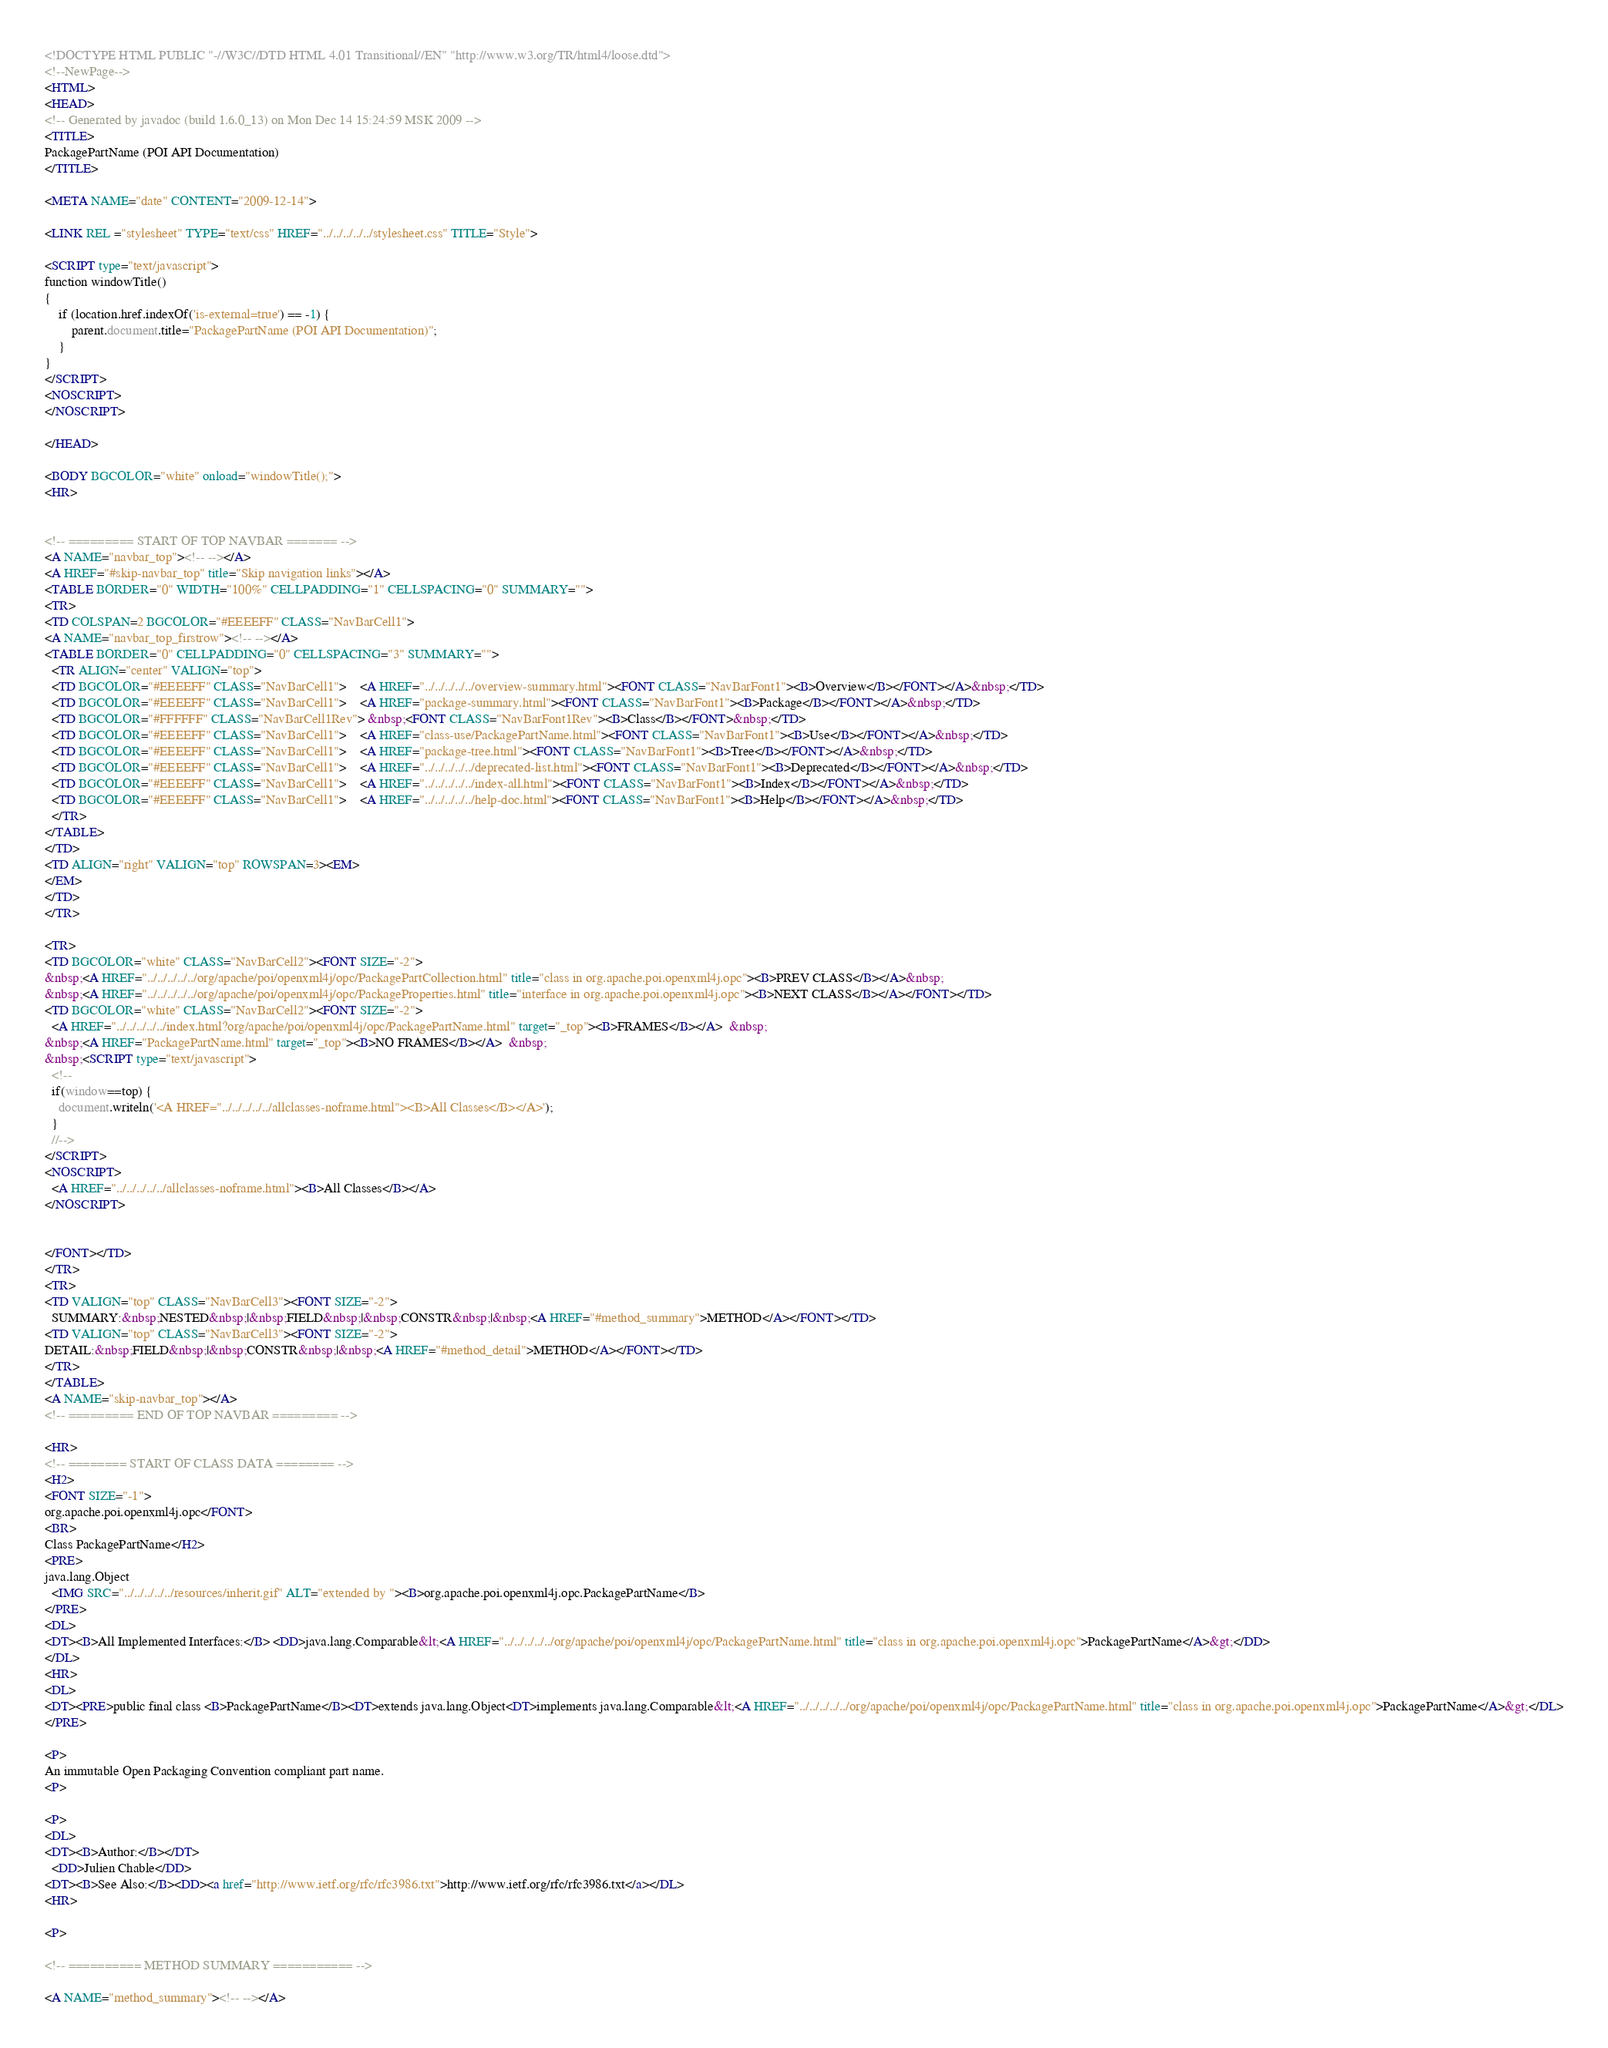Convert code to text. <code><loc_0><loc_0><loc_500><loc_500><_HTML_><!DOCTYPE HTML PUBLIC "-//W3C//DTD HTML 4.01 Transitional//EN" "http://www.w3.org/TR/html4/loose.dtd">
<!--NewPage-->
<HTML>
<HEAD>
<!-- Generated by javadoc (build 1.6.0_13) on Mon Dec 14 15:24:59 MSK 2009 -->
<TITLE>
PackagePartName (POI API Documentation)
</TITLE>

<META NAME="date" CONTENT="2009-12-14">

<LINK REL ="stylesheet" TYPE="text/css" HREF="../../../../../stylesheet.css" TITLE="Style">

<SCRIPT type="text/javascript">
function windowTitle()
{
    if (location.href.indexOf('is-external=true') == -1) {
        parent.document.title="PackagePartName (POI API Documentation)";
    }
}
</SCRIPT>
<NOSCRIPT>
</NOSCRIPT>

</HEAD>

<BODY BGCOLOR="white" onload="windowTitle();">
<HR>


<!-- ========= START OF TOP NAVBAR ======= -->
<A NAME="navbar_top"><!-- --></A>
<A HREF="#skip-navbar_top" title="Skip navigation links"></A>
<TABLE BORDER="0" WIDTH="100%" CELLPADDING="1" CELLSPACING="0" SUMMARY="">
<TR>
<TD COLSPAN=2 BGCOLOR="#EEEEFF" CLASS="NavBarCell1">
<A NAME="navbar_top_firstrow"><!-- --></A>
<TABLE BORDER="0" CELLPADDING="0" CELLSPACING="3" SUMMARY="">
  <TR ALIGN="center" VALIGN="top">
  <TD BGCOLOR="#EEEEFF" CLASS="NavBarCell1">    <A HREF="../../../../../overview-summary.html"><FONT CLASS="NavBarFont1"><B>Overview</B></FONT></A>&nbsp;</TD>
  <TD BGCOLOR="#EEEEFF" CLASS="NavBarCell1">    <A HREF="package-summary.html"><FONT CLASS="NavBarFont1"><B>Package</B></FONT></A>&nbsp;</TD>
  <TD BGCOLOR="#FFFFFF" CLASS="NavBarCell1Rev"> &nbsp;<FONT CLASS="NavBarFont1Rev"><B>Class</B></FONT>&nbsp;</TD>
  <TD BGCOLOR="#EEEEFF" CLASS="NavBarCell1">    <A HREF="class-use/PackagePartName.html"><FONT CLASS="NavBarFont1"><B>Use</B></FONT></A>&nbsp;</TD>
  <TD BGCOLOR="#EEEEFF" CLASS="NavBarCell1">    <A HREF="package-tree.html"><FONT CLASS="NavBarFont1"><B>Tree</B></FONT></A>&nbsp;</TD>
  <TD BGCOLOR="#EEEEFF" CLASS="NavBarCell1">    <A HREF="../../../../../deprecated-list.html"><FONT CLASS="NavBarFont1"><B>Deprecated</B></FONT></A>&nbsp;</TD>
  <TD BGCOLOR="#EEEEFF" CLASS="NavBarCell1">    <A HREF="../../../../../index-all.html"><FONT CLASS="NavBarFont1"><B>Index</B></FONT></A>&nbsp;</TD>
  <TD BGCOLOR="#EEEEFF" CLASS="NavBarCell1">    <A HREF="../../../../../help-doc.html"><FONT CLASS="NavBarFont1"><B>Help</B></FONT></A>&nbsp;</TD>
  </TR>
</TABLE>
</TD>
<TD ALIGN="right" VALIGN="top" ROWSPAN=3><EM>
</EM>
</TD>
</TR>

<TR>
<TD BGCOLOR="white" CLASS="NavBarCell2"><FONT SIZE="-2">
&nbsp;<A HREF="../../../../../org/apache/poi/openxml4j/opc/PackagePartCollection.html" title="class in org.apache.poi.openxml4j.opc"><B>PREV CLASS</B></A>&nbsp;
&nbsp;<A HREF="../../../../../org/apache/poi/openxml4j/opc/PackageProperties.html" title="interface in org.apache.poi.openxml4j.opc"><B>NEXT CLASS</B></A></FONT></TD>
<TD BGCOLOR="white" CLASS="NavBarCell2"><FONT SIZE="-2">
  <A HREF="../../../../../index.html?org/apache/poi/openxml4j/opc/PackagePartName.html" target="_top"><B>FRAMES</B></A>  &nbsp;
&nbsp;<A HREF="PackagePartName.html" target="_top"><B>NO FRAMES</B></A>  &nbsp;
&nbsp;<SCRIPT type="text/javascript">
  <!--
  if(window==top) {
    document.writeln('<A HREF="../../../../../allclasses-noframe.html"><B>All Classes</B></A>');
  }
  //-->
</SCRIPT>
<NOSCRIPT>
  <A HREF="../../../../../allclasses-noframe.html"><B>All Classes</B></A>
</NOSCRIPT>


</FONT></TD>
</TR>
<TR>
<TD VALIGN="top" CLASS="NavBarCell3"><FONT SIZE="-2">
  SUMMARY:&nbsp;NESTED&nbsp;|&nbsp;FIELD&nbsp;|&nbsp;CONSTR&nbsp;|&nbsp;<A HREF="#method_summary">METHOD</A></FONT></TD>
<TD VALIGN="top" CLASS="NavBarCell3"><FONT SIZE="-2">
DETAIL:&nbsp;FIELD&nbsp;|&nbsp;CONSTR&nbsp;|&nbsp;<A HREF="#method_detail">METHOD</A></FONT></TD>
</TR>
</TABLE>
<A NAME="skip-navbar_top"></A>
<!-- ========= END OF TOP NAVBAR ========= -->

<HR>
<!-- ======== START OF CLASS DATA ======== -->
<H2>
<FONT SIZE="-1">
org.apache.poi.openxml4j.opc</FONT>
<BR>
Class PackagePartName</H2>
<PRE>
java.lang.Object
  <IMG SRC="../../../../../resources/inherit.gif" ALT="extended by "><B>org.apache.poi.openxml4j.opc.PackagePartName</B>
</PRE>
<DL>
<DT><B>All Implemented Interfaces:</B> <DD>java.lang.Comparable&lt;<A HREF="../../../../../org/apache/poi/openxml4j/opc/PackagePartName.html" title="class in org.apache.poi.openxml4j.opc">PackagePartName</A>&gt;</DD>
</DL>
<HR>
<DL>
<DT><PRE>public final class <B>PackagePartName</B><DT>extends java.lang.Object<DT>implements java.lang.Comparable&lt;<A HREF="../../../../../org/apache/poi/openxml4j/opc/PackagePartName.html" title="class in org.apache.poi.openxml4j.opc">PackagePartName</A>&gt;</DL>
</PRE>

<P>
An immutable Open Packaging Convention compliant part name.
<P>

<P>
<DL>
<DT><B>Author:</B></DT>
  <DD>Julien Chable</DD>
<DT><B>See Also:</B><DD><a href="http://www.ietf.org/rfc/rfc3986.txt">http://www.ietf.org/rfc/rfc3986.txt</a></DL>
<HR>

<P>

<!-- ========== METHOD SUMMARY =========== -->

<A NAME="method_summary"><!-- --></A></code> 